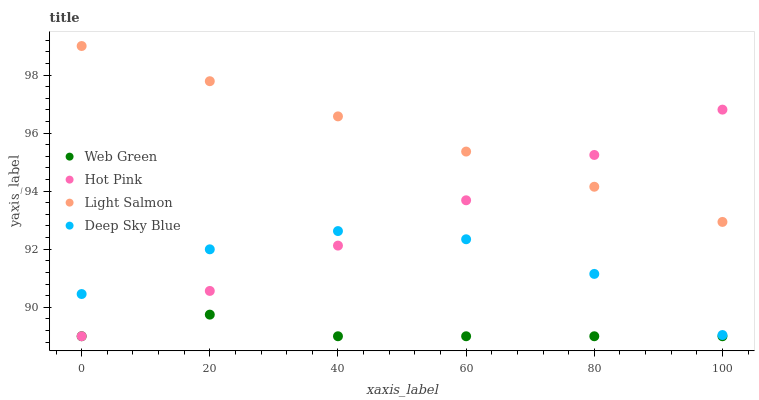Does Web Green have the minimum area under the curve?
Answer yes or no. Yes. Does Light Salmon have the maximum area under the curve?
Answer yes or no. Yes. Does Hot Pink have the minimum area under the curve?
Answer yes or no. No. Does Hot Pink have the maximum area under the curve?
Answer yes or no. No. Is Light Salmon the smoothest?
Answer yes or no. Yes. Is Deep Sky Blue the roughest?
Answer yes or no. Yes. Is Deep Sky Blue the smoothest?
Answer yes or no. No. Is Hot Pink the roughest?
Answer yes or no. No. Does Hot Pink have the lowest value?
Answer yes or no. Yes. Does Deep Sky Blue have the lowest value?
Answer yes or no. No. Does Light Salmon have the highest value?
Answer yes or no. Yes. Does Hot Pink have the highest value?
Answer yes or no. No. Is Web Green less than Deep Sky Blue?
Answer yes or no. Yes. Is Light Salmon greater than Deep Sky Blue?
Answer yes or no. Yes. Does Deep Sky Blue intersect Hot Pink?
Answer yes or no. Yes. Is Deep Sky Blue less than Hot Pink?
Answer yes or no. No. Is Deep Sky Blue greater than Hot Pink?
Answer yes or no. No. Does Web Green intersect Deep Sky Blue?
Answer yes or no. No. 